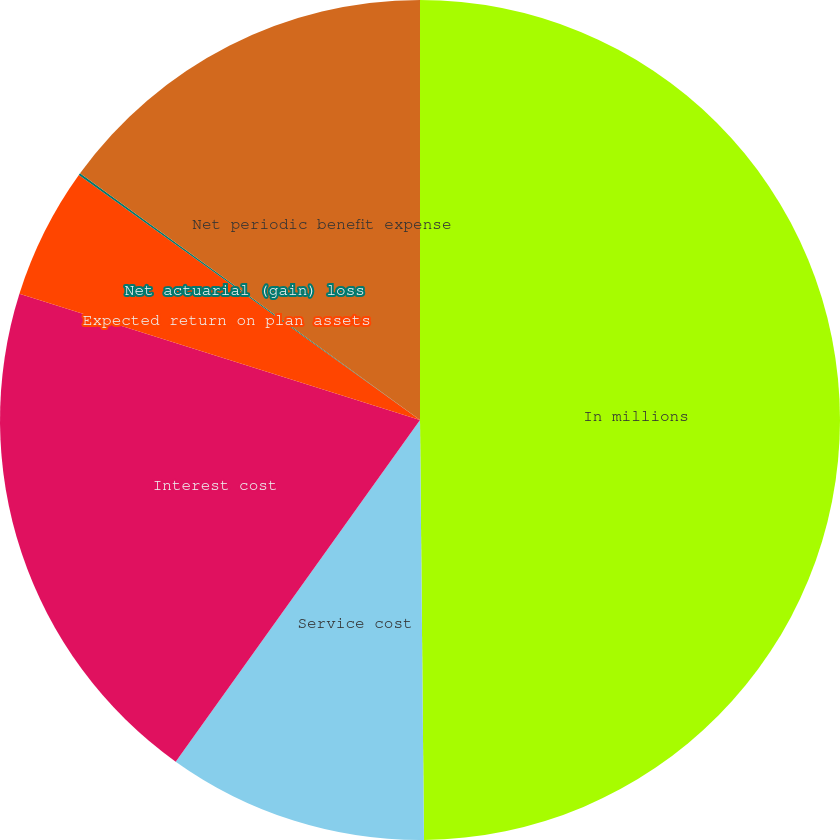<chart> <loc_0><loc_0><loc_500><loc_500><pie_chart><fcel>In millions<fcel>Service cost<fcel>Interest cost<fcel>Expected return on plan assets<fcel>Net actuarial (gain) loss<fcel>Net periodic benefit expense<nl><fcel>49.85%<fcel>10.03%<fcel>19.98%<fcel>5.05%<fcel>0.08%<fcel>15.01%<nl></chart> 